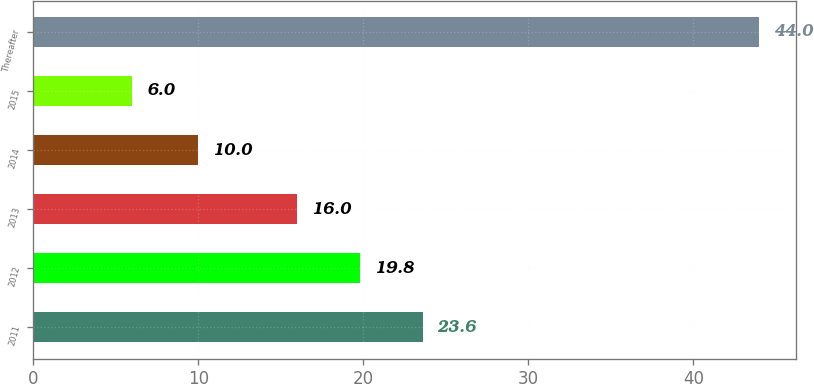<chart> <loc_0><loc_0><loc_500><loc_500><bar_chart><fcel>2011<fcel>2012<fcel>2013<fcel>2014<fcel>2015<fcel>Thereafter<nl><fcel>23.6<fcel>19.8<fcel>16<fcel>10<fcel>6<fcel>44<nl></chart> 